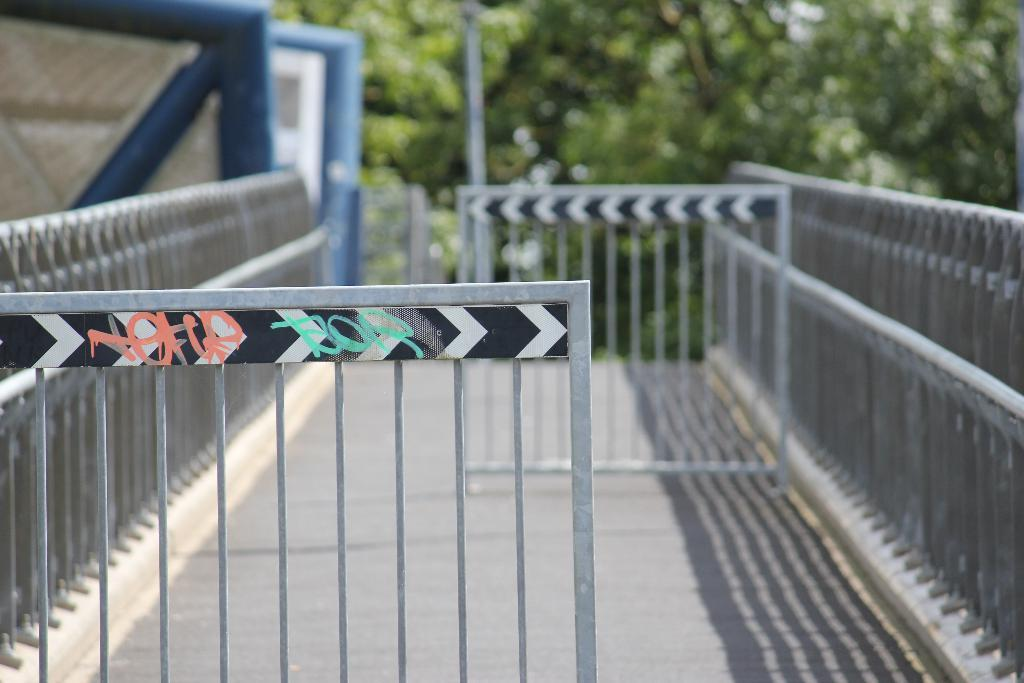What type of structures can be seen in the image? There are fences in the image. What color and location are the objects in the left corner of the image? There are blue color objects in the left corner of the image. What can be seen in the background of the image? There are trees in the background of the image. What type of teeth can be seen in the image? There are no teeth visible in the image. Is the person's father present in the image? There is no person or father mentioned or visible in the image. 